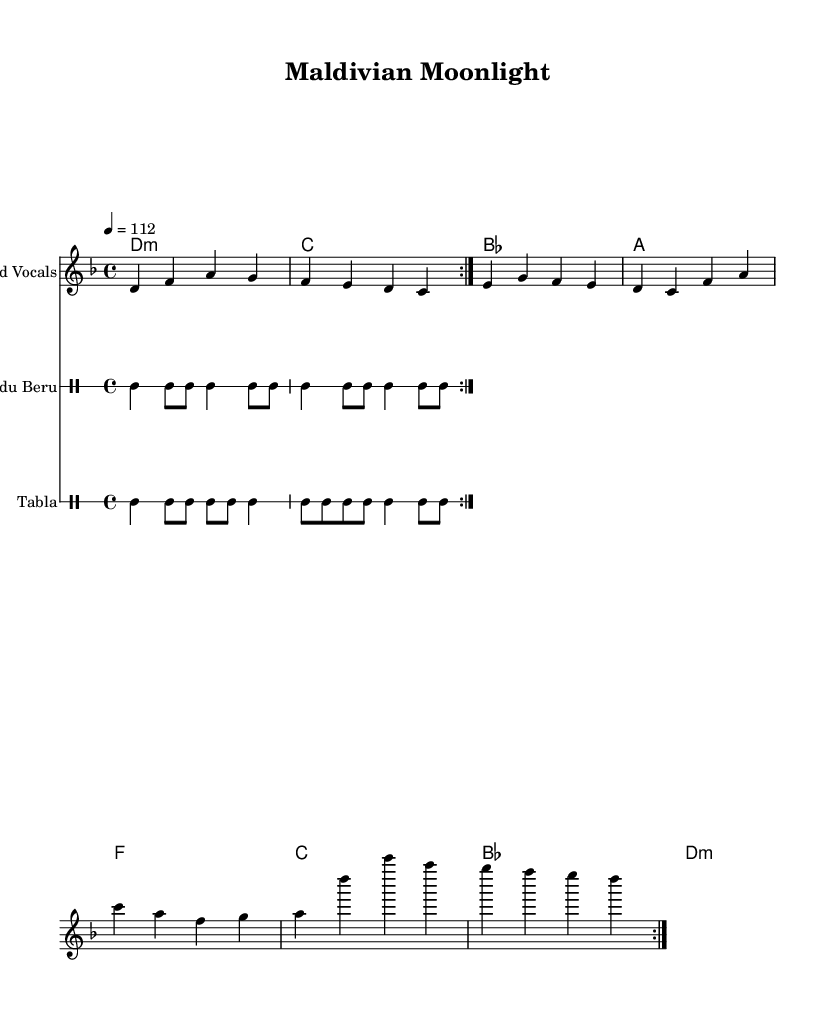What is the key signature of this music? The key signature is D minor, which has one flat (B flat). This is indicated at the beginning of the staff.
Answer: D minor What is the time signature of this music? The time signature is 4/4, which means there are four beats in each measure. This can be seen at the beginning of the score.
Answer: 4/4 What is the tempo marking of this piece? The tempo marking is 112 beats per minute, indicated by "4 = 112" at the beginning of the music.
Answer: 112 How many measures are there in the melody section? The melody section consists of 8 measures, which can be counted in the repeating structure of the music. Each repeat contains 4 measures, and there are 2 repeats.
Answer: 8 What type of percussion is featured alongside the melodies? The percussion includes Bodu Beru and Tabla, which are specified as separate drum staffs in the score.
Answer: Bodu Beru and Tabla What pattern is used for the Bodu Beru? The Bodu Beru pattern is indicated with a specific rhythmic sequence that includes bass drum hits and snare notes, repeated twice.
Answer: Bass and snare pattern What unique blend is represented in this piece? The piece represents a fusion of Contemporary Bollywood-inspired pop with traditional Dhivehi rhythms. This is indicated by the style of the melody and the rhythmic patterns of the percussion.
Answer: Fusion of Contemporary Bollywood and Dhivehi rhythms 